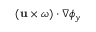Convert formula to latex. <formula><loc_0><loc_0><loc_500><loc_500>( u \times \omega ) \cdot \nabla \phi _ { y }</formula> 